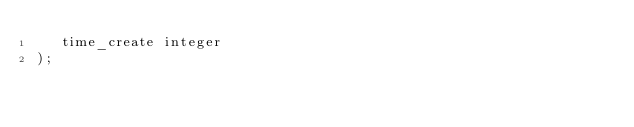Convert code to text. <code><loc_0><loc_0><loc_500><loc_500><_SQL_>   time_create integer
);</code> 